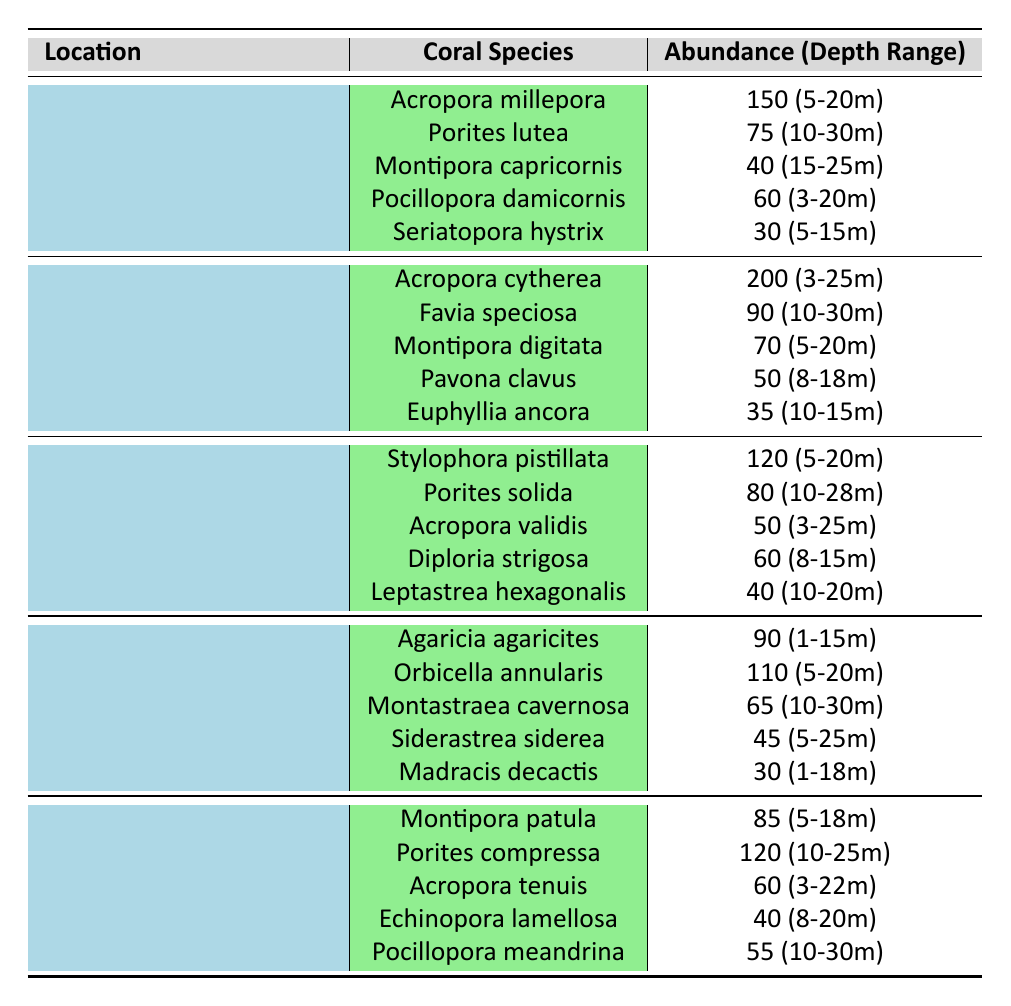What is the total abundance of coral species in the Great Barrier Reef? The total abundance is calculated by adding the abundance values of all coral species listed for the Great Barrier Reef: 150 + 75 + 40 + 60 + 30 = 355.
Answer: 355 Which coral species has the highest abundance in the Coral Triangle? The species with the highest abundance in the Coral Triangle is Acropora cytherea, which has an abundance of 200.
Answer: Acropora cytherea What is the depth range of Acropora millepora in the Great Barrier Reef? Looking at the data for Acropora millepora under the Great Barrier Reef location, its depth range is specified as 5-20 meters.
Answer: 5-20 meters Is there any coral species in the Caribbean Sea with an abundance greater than 100? The only species with an abundance greater than 100 in the Caribbean Sea is Orbicella annularis, which has an abundance of 110.
Answer: Yes How many coral species have an abundance of 60 or more in the Hawaiian Islands? The coral species with abundance of 60 or more in the Hawaiian Islands are Porites compressa (120), Montipora patula (85), and Acropora tenuis (60). Counting these gives 3 species.
Answer: 3 What is the average abundance of coral species in the Red Sea? To find the average, sum the abundances: 120 + 80 + 50 + 60 + 40 = 350, and there are 5 species. The average is 350 / 5 = 70.
Answer: 70 Which reef location has the lowest total abundance of coral species? First, calculate the total abundances: Great Barrier Reef = 355, Coral Triangle = 445, Red Sea = 350, Caribbean Sea = 340, Hawaiian Islands = 410. The lowest total abundance is found in the Caribbean Sea at 340.
Answer: Caribbean Sea Which coral species has the smallest abundance in the Coral Triangle? In the Coral Triangle, Euphyllia ancora has the smallest abundance value at 35.
Answer: Euphyllia ancora What is the difference in abundance between the highest and lowest species in the Great Barrier Reef? The highest abundance species in the Great Barrier Reef is Acropora millepora (150), and the lowest is Seriatopora hystrix (30). The difference is 150 - 30 = 120.
Answer: 120 Are there more coral species with depth ranges above 20 meters in the Caribbean Sea compared to the Great Barrier Reef? Upon examining the tables, both locations show no coral species with a depth range extending beyond 20 meters. Hence, the answer is no, neither has more species over 20 meters.
Answer: No 